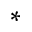Convert formula to latex. <formula><loc_0><loc_0><loc_500><loc_500>^ { * }</formula> 